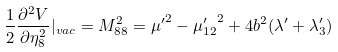<formula> <loc_0><loc_0><loc_500><loc_500>\frac { 1 } { 2 } \frac { \partial ^ { 2 } V } { \partial \eta _ { 8 } ^ { 2 } } | _ { v a c } = M _ { 8 8 } ^ { 2 } = { \mu ^ { \prime } } ^ { 2 } - { \mu _ { 1 2 } ^ { \prime } } ^ { 2 } + 4 b ^ { 2 } ( \lambda ^ { \prime } + \lambda _ { 3 } ^ { \prime } )</formula> 